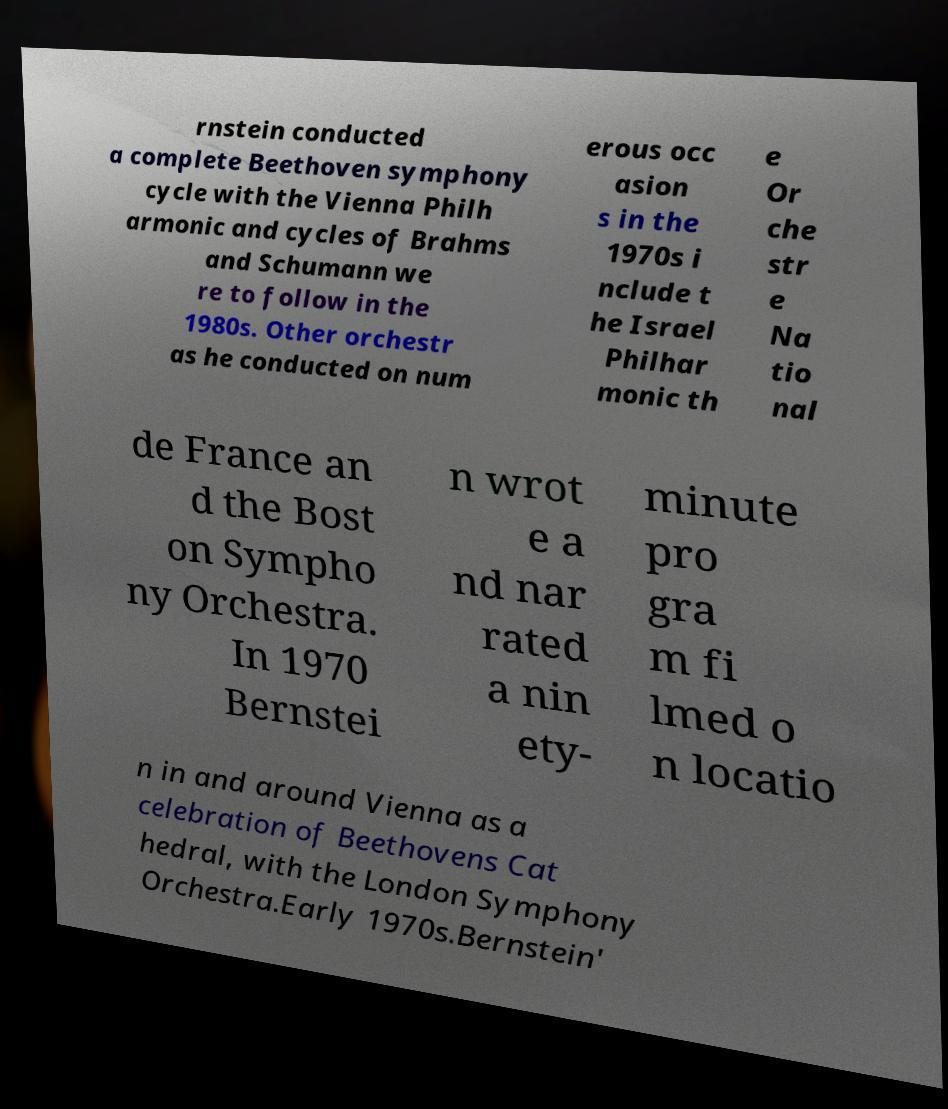Could you extract and type out the text from this image? rnstein conducted a complete Beethoven symphony cycle with the Vienna Philh armonic and cycles of Brahms and Schumann we re to follow in the 1980s. Other orchestr as he conducted on num erous occ asion s in the 1970s i nclude t he Israel Philhar monic th e Or che str e Na tio nal de France an d the Bost on Sympho ny Orchestra. In 1970 Bernstei n wrot e a nd nar rated a nin ety- minute pro gra m fi lmed o n locatio n in and around Vienna as a celebration of Beethovens Cat hedral, with the London Symphony Orchestra.Early 1970s.Bernstein' 